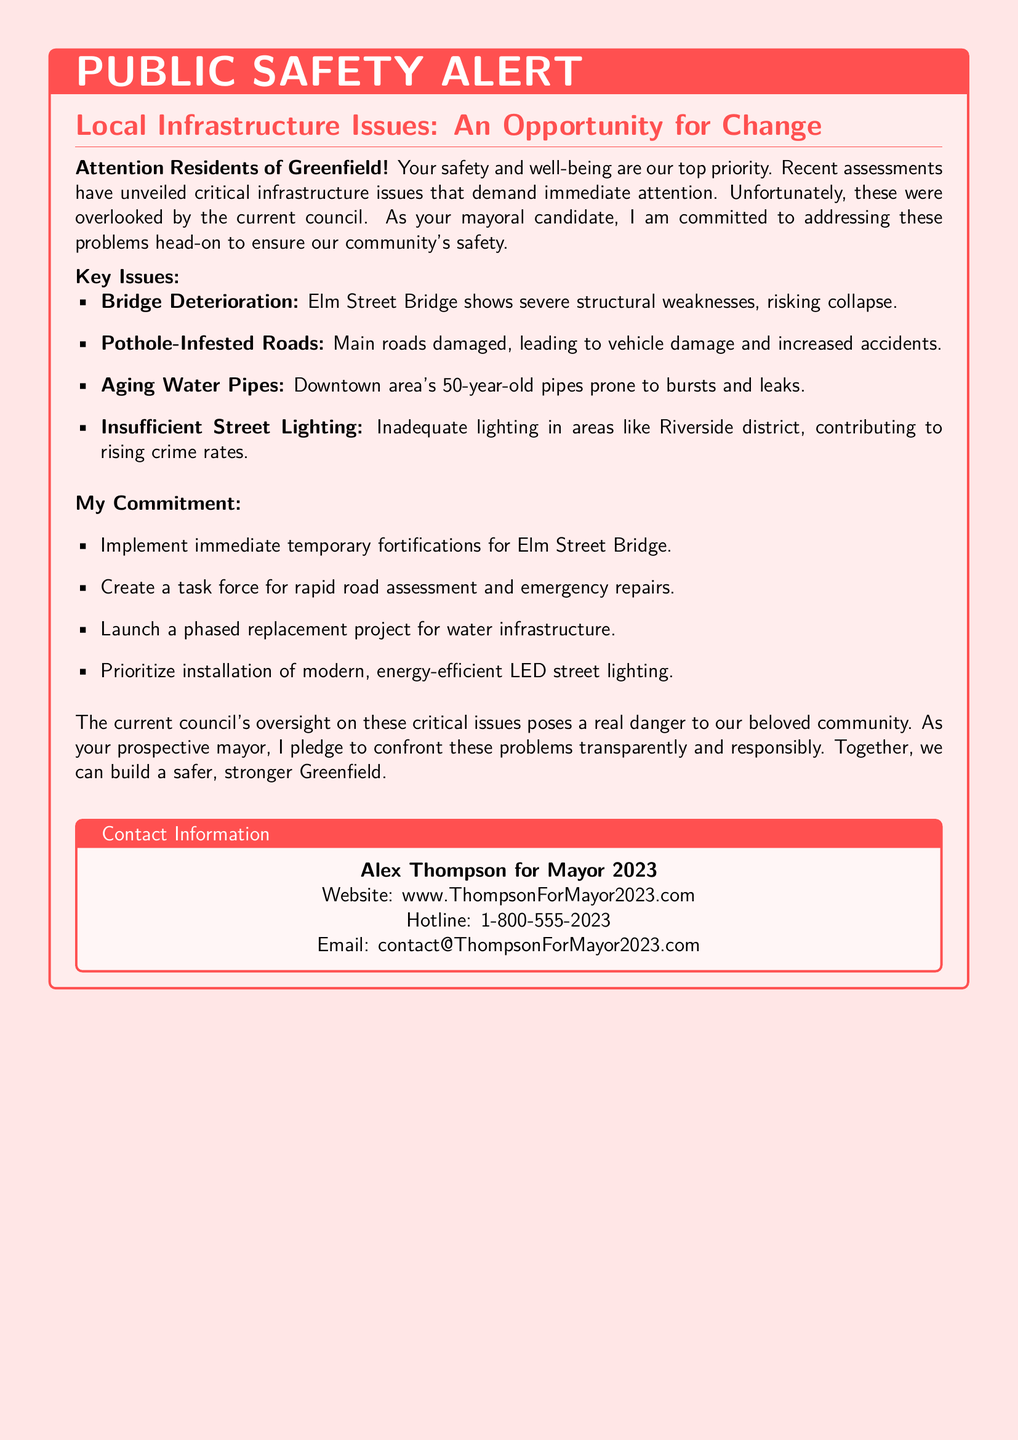What is the top priority mentioned in the alert? The alert states that the top priority is the safety and well-being of the residents.
Answer: safety and well-being What are the key issues identified? The document presents four key infrastructure issues, including bridge deterioration, pothole-infested roads, aging water pipes, and insufficient street lighting.
Answer: bridge deterioration, pothole-infested roads, aging water pipes, insufficient street lighting How old are the water pipes in Downtown area? The document indicates that the water pipes are 50 years old.
Answer: 50 years old What commitment will be made for Elm Street Bridge? The commitment includes implementing immediate temporary fortifications for the Elm Street Bridge.
Answer: immediate temporary fortifications What is the email contact for Alex Thompson's campaign? The email address for contact is provided in the alert.
Answer: contact@ThompsonForMayor2023.com What lighting solution is prioritized in the commitment? The document specifies prioritizing the installation of modern, energy-efficient LED street lighting.
Answer: modern, energy-efficient LED street lighting In which district is there insufficient street lighting mentioned? The Riverside district is mentioned as having inadequate lighting.
Answer: Riverside district What does this public safety alert call for regarding the council's actions? The alert highlights the council's oversight on critical issues as posing a danger to the community.
Answer: oversight on critical issues 